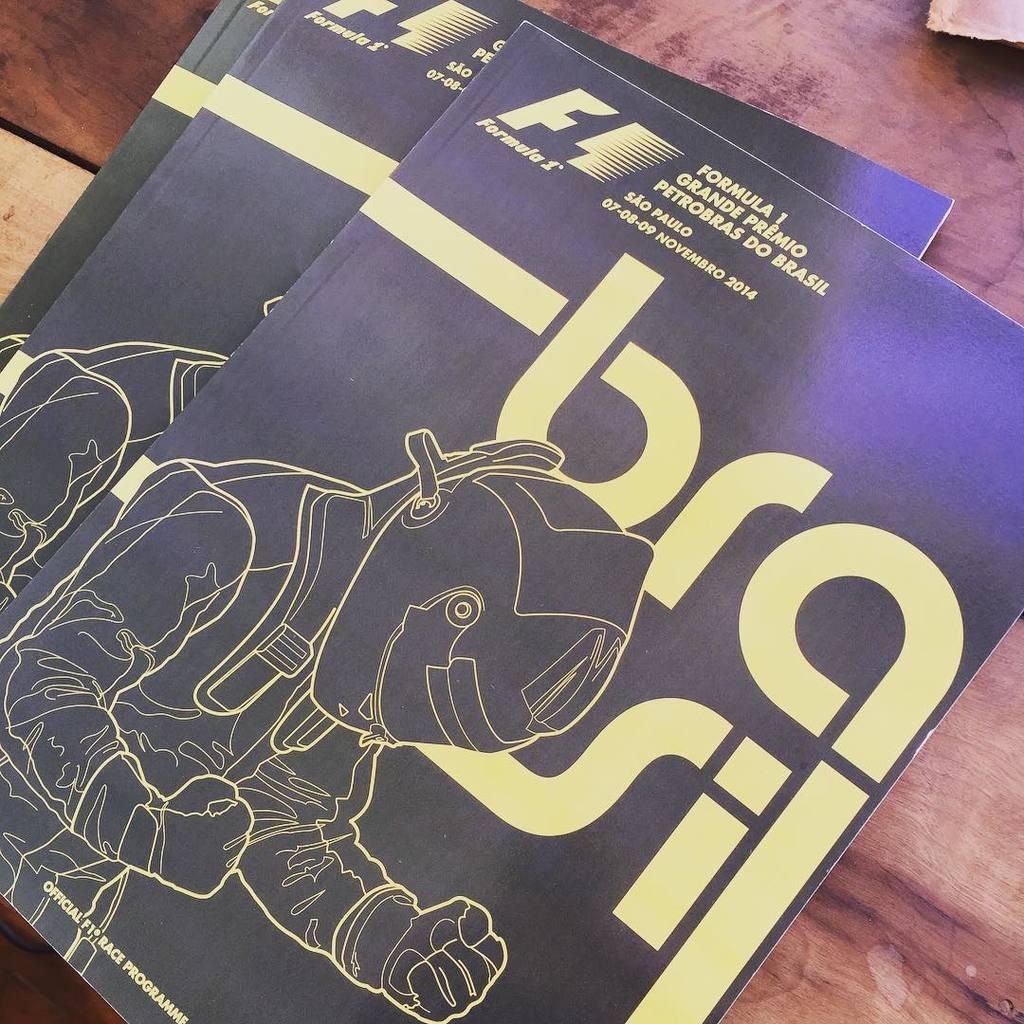What is the company that produce this magazine?
Your response must be concise. Formula 1. What date was this magazine made?
Keep it short and to the point. Unanswerable. 